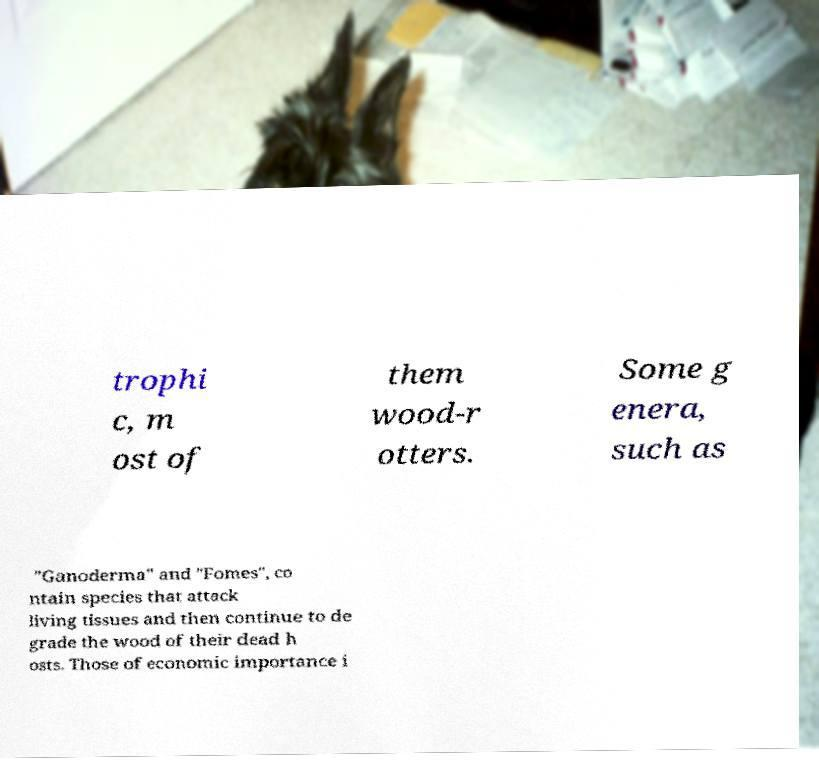I need the written content from this picture converted into text. Can you do that? trophi c, m ost of them wood-r otters. Some g enera, such as "Ganoderma" and "Fomes", co ntain species that attack living tissues and then continue to de grade the wood of their dead h osts. Those of economic importance i 